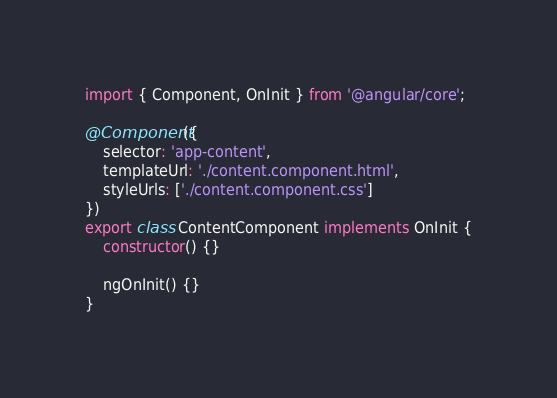Convert code to text. <code><loc_0><loc_0><loc_500><loc_500><_TypeScript_>import { Component, OnInit } from '@angular/core';

@Component({
    selector: 'app-content',
    templateUrl: './content.component.html',
    styleUrls: ['./content.component.css']
})
export class ContentComponent implements OnInit {
    constructor() {}

    ngOnInit() {}
}
</code> 